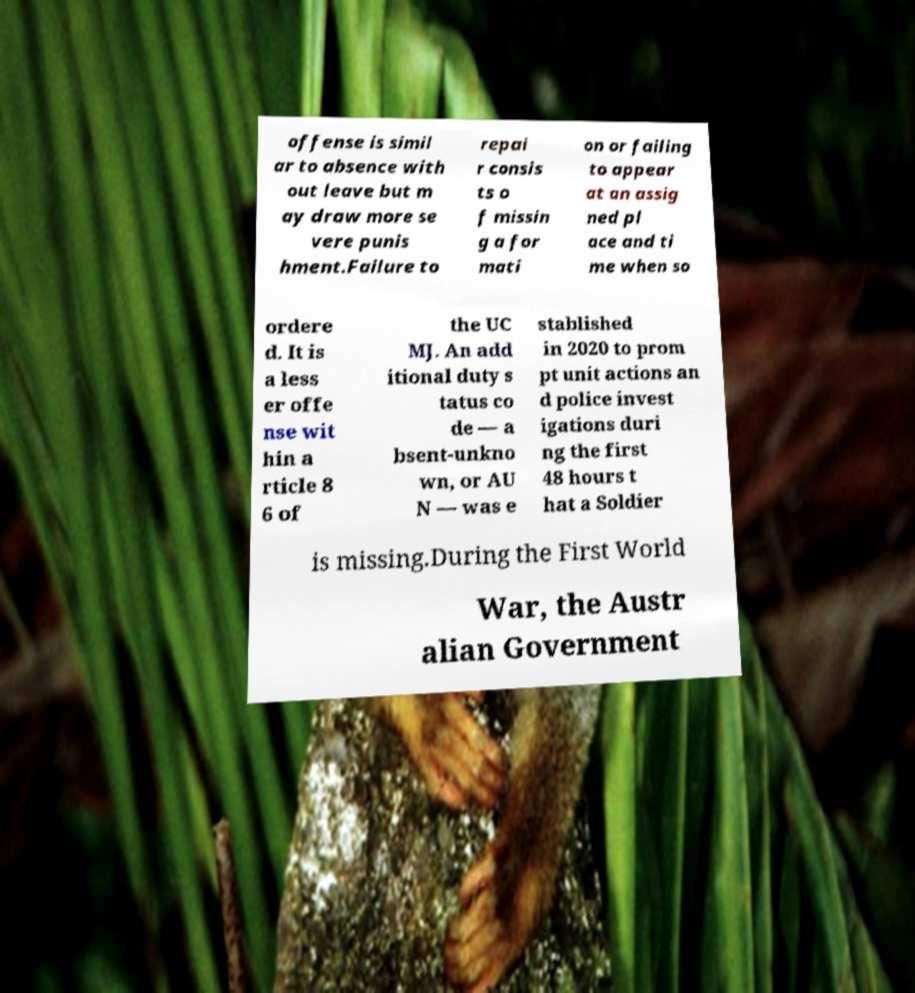Can you accurately transcribe the text from the provided image for me? offense is simil ar to absence with out leave but m ay draw more se vere punis hment.Failure to repai r consis ts o f missin g a for mati on or failing to appear at an assig ned pl ace and ti me when so ordere d. It is a less er offe nse wit hin a rticle 8 6 of the UC MJ. An add itional duty s tatus co de — a bsent-unkno wn, or AU N — was e stablished in 2020 to prom pt unit actions an d police invest igations duri ng the first 48 hours t hat a Soldier is missing.During the First World War, the Austr alian Government 